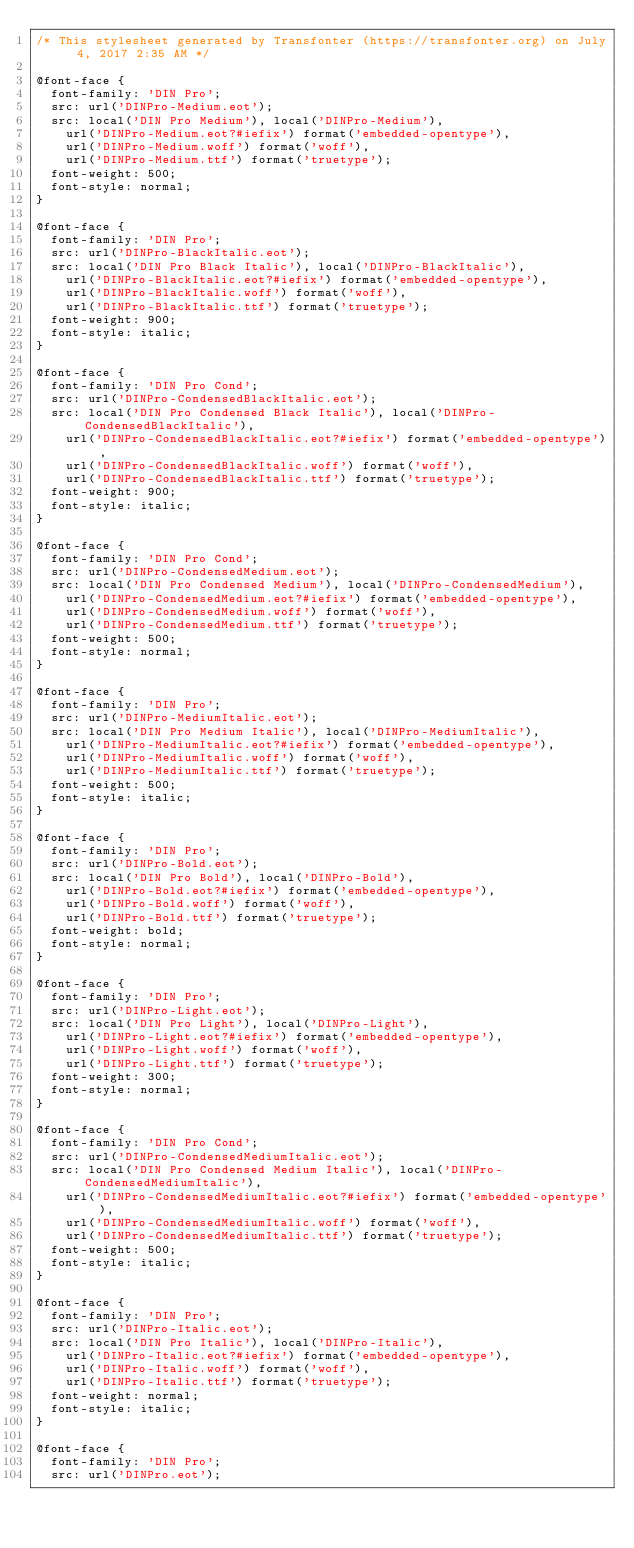Convert code to text. <code><loc_0><loc_0><loc_500><loc_500><_CSS_>/* This stylesheet generated by Transfonter (https://transfonter.org) on July 4, 2017 2:35 AM */

@font-face {
	font-family: 'DIN Pro';
	src: url('DINPro-Medium.eot');
	src: local('DIN Pro Medium'), local('DINPro-Medium'),
		url('DINPro-Medium.eot?#iefix') format('embedded-opentype'),
		url('DINPro-Medium.woff') format('woff'),
		url('DINPro-Medium.ttf') format('truetype');
	font-weight: 500;
	font-style: normal;
}

@font-face {
	font-family: 'DIN Pro';
	src: url('DINPro-BlackItalic.eot');
	src: local('DIN Pro Black Italic'), local('DINPro-BlackItalic'),
		url('DINPro-BlackItalic.eot?#iefix') format('embedded-opentype'),
		url('DINPro-BlackItalic.woff') format('woff'),
		url('DINPro-BlackItalic.ttf') format('truetype');
	font-weight: 900;
	font-style: italic;
}

@font-face {
	font-family: 'DIN Pro Cond';
	src: url('DINPro-CondensedBlackItalic.eot');
	src: local('DIN Pro Condensed Black Italic'), local('DINPro-CondensedBlackItalic'),
		url('DINPro-CondensedBlackItalic.eot?#iefix') format('embedded-opentype'),
		url('DINPro-CondensedBlackItalic.woff') format('woff'),
		url('DINPro-CondensedBlackItalic.ttf') format('truetype');
	font-weight: 900;
	font-style: italic;
}

@font-face {
	font-family: 'DIN Pro Cond';
	src: url('DINPro-CondensedMedium.eot');
	src: local('DIN Pro Condensed Medium'), local('DINPro-CondensedMedium'),
		url('DINPro-CondensedMedium.eot?#iefix') format('embedded-opentype'),
		url('DINPro-CondensedMedium.woff') format('woff'),
		url('DINPro-CondensedMedium.ttf') format('truetype');
	font-weight: 500;
	font-style: normal;
}

@font-face {
	font-family: 'DIN Pro';
	src: url('DINPro-MediumItalic.eot');
	src: local('DIN Pro Medium Italic'), local('DINPro-MediumItalic'),
		url('DINPro-MediumItalic.eot?#iefix') format('embedded-opentype'),
		url('DINPro-MediumItalic.woff') format('woff'),
		url('DINPro-MediumItalic.ttf') format('truetype');
	font-weight: 500;
	font-style: italic;
}

@font-face {
	font-family: 'DIN Pro';
	src: url('DINPro-Bold.eot');
	src: local('DIN Pro Bold'), local('DINPro-Bold'),
		url('DINPro-Bold.eot?#iefix') format('embedded-opentype'),
		url('DINPro-Bold.woff') format('woff'),
		url('DINPro-Bold.ttf') format('truetype');
	font-weight: bold;
	font-style: normal;
}

@font-face {
	font-family: 'DIN Pro';
	src: url('DINPro-Light.eot');
	src: local('DIN Pro Light'), local('DINPro-Light'),
		url('DINPro-Light.eot?#iefix') format('embedded-opentype'),
		url('DINPro-Light.woff') format('woff'),
		url('DINPro-Light.ttf') format('truetype');
	font-weight: 300;
	font-style: normal;
}

@font-face {
	font-family: 'DIN Pro Cond';
	src: url('DINPro-CondensedMediumItalic.eot');
	src: local('DIN Pro Condensed Medium Italic'), local('DINPro-CondensedMediumItalic'),
		url('DINPro-CondensedMediumItalic.eot?#iefix') format('embedded-opentype'),
		url('DINPro-CondensedMediumItalic.woff') format('woff'),
		url('DINPro-CondensedMediumItalic.ttf') format('truetype');
	font-weight: 500;
	font-style: italic;
}

@font-face {
	font-family: 'DIN Pro';
	src: url('DINPro-Italic.eot');
	src: local('DIN Pro Italic'), local('DINPro-Italic'),
		url('DINPro-Italic.eot?#iefix') format('embedded-opentype'),
		url('DINPro-Italic.woff') format('woff'),
		url('DINPro-Italic.ttf') format('truetype');
	font-weight: normal;
	font-style: italic;
}

@font-face {
	font-family: 'DIN Pro';
	src: url('DINPro.eot');</code> 